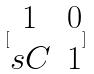Convert formula to latex. <formula><loc_0><loc_0><loc_500><loc_500>[ \begin{matrix} 1 & 0 \\ s C & 1 \end{matrix} ]</formula> 